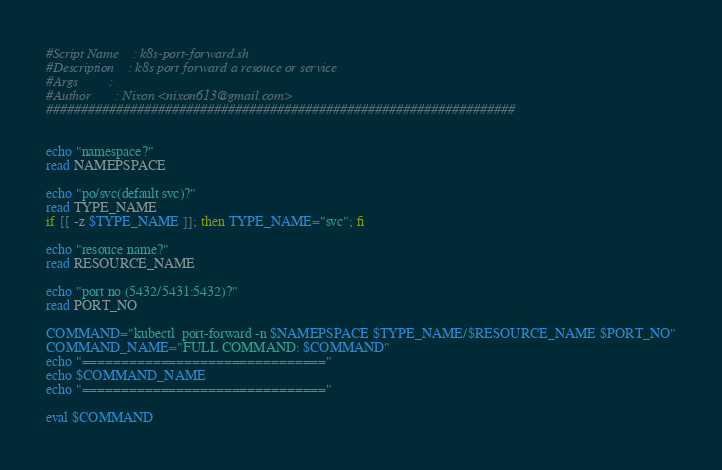Convert code to text. <code><loc_0><loc_0><loc_500><loc_500><_Bash_>#Script Name	: k8s-port-forward.sh                                                                                      
#Description	: k8s port forward a resouce or service                                                                    
#Args         :                                                                                           
#Author       : Nixon <nixon613@gmail.com>
###################################################################


echo "namespace?"
read NAMEPSPACE

echo "po/svc(default svc)?"
read TYPE_NAME
if [[ -z $TYPE_NAME ]]; then TYPE_NAME="svc"; fi

echo "resouce name?"
read RESOURCE_NAME

echo "port no (5432/5431:5432)?"
read PORT_NO

COMMAND="kubectl  port-forward -n $NAMEPSPACE $TYPE_NAME/$RESOURCE_NAME $PORT_NO"
COMMAND_NAME="FULL COMMAND: $COMMAND"
echo "==============================="
echo $COMMAND_NAME
echo "==============================="

eval $COMMAND</code> 